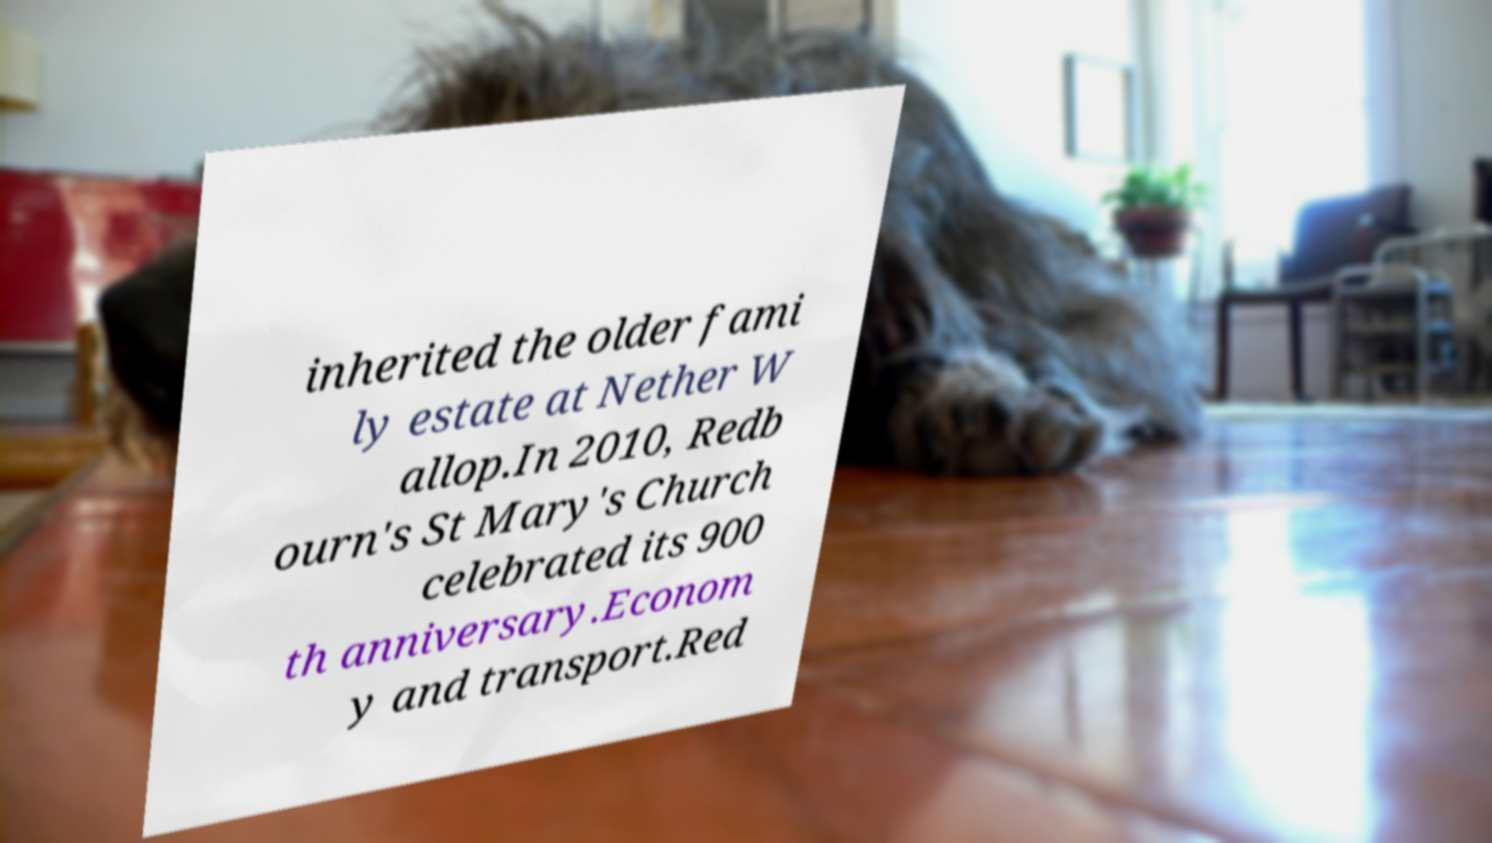For documentation purposes, I need the text within this image transcribed. Could you provide that? inherited the older fami ly estate at Nether W allop.In 2010, Redb ourn's St Mary's Church celebrated its 900 th anniversary.Econom y and transport.Red 